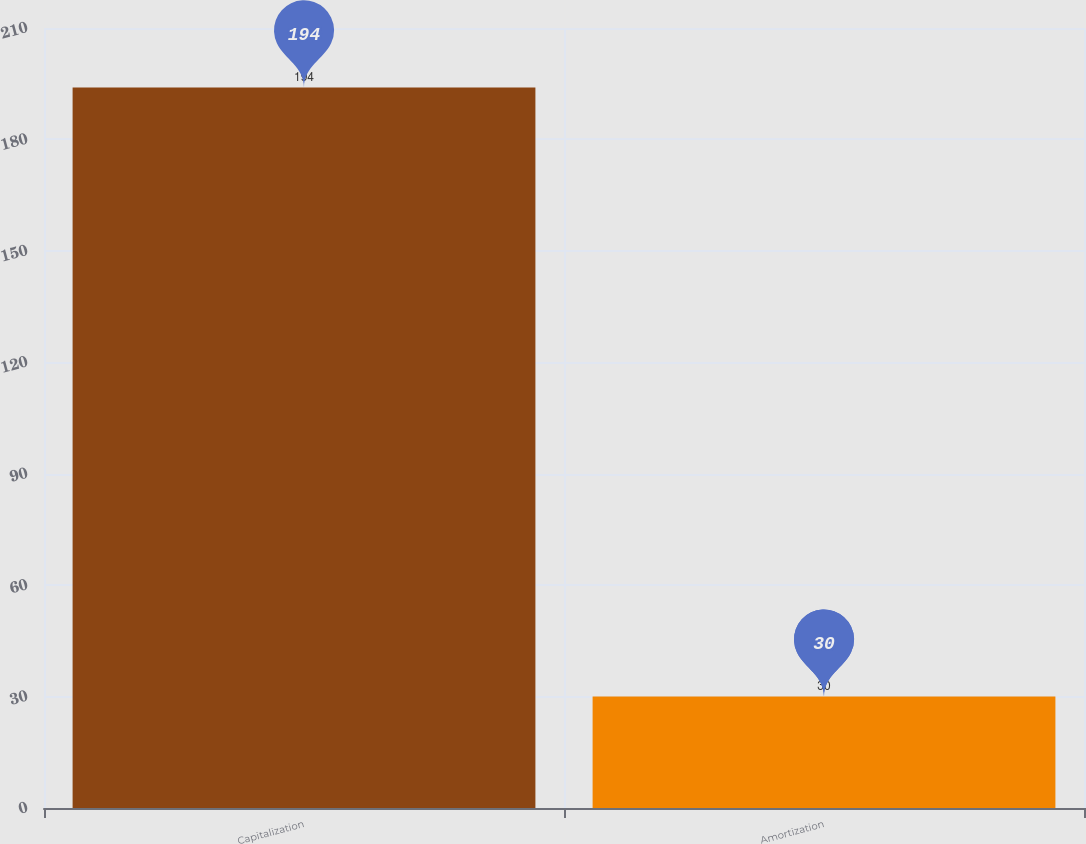Convert chart. <chart><loc_0><loc_0><loc_500><loc_500><bar_chart><fcel>Capitalization<fcel>Amortization<nl><fcel>194<fcel>30<nl></chart> 